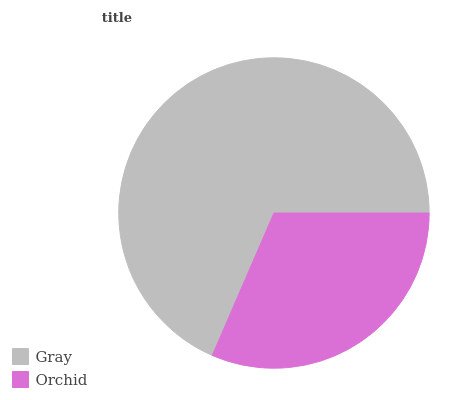Is Orchid the minimum?
Answer yes or no. Yes. Is Gray the maximum?
Answer yes or no. Yes. Is Orchid the maximum?
Answer yes or no. No. Is Gray greater than Orchid?
Answer yes or no. Yes. Is Orchid less than Gray?
Answer yes or no. Yes. Is Orchid greater than Gray?
Answer yes or no. No. Is Gray less than Orchid?
Answer yes or no. No. Is Gray the high median?
Answer yes or no. Yes. Is Orchid the low median?
Answer yes or no. Yes. Is Orchid the high median?
Answer yes or no. No. Is Gray the low median?
Answer yes or no. No. 